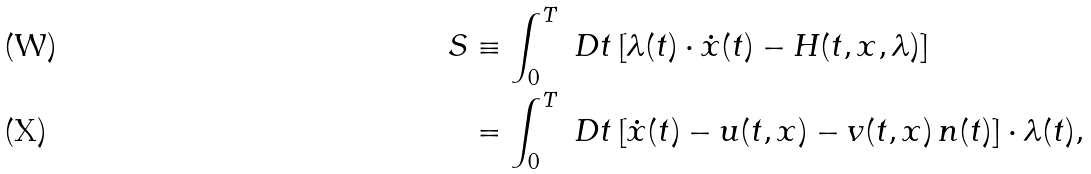<formula> <loc_0><loc_0><loc_500><loc_500>S & \equiv \int _ { 0 } ^ { T } \ D t \, [ \lambda ( t ) \cdot \dot { x } ( t ) - H ( t , x , \lambda ) ] \\ & = \int _ { 0 } ^ { T } \ D t \, [ \dot { x } ( t ) - u ( t , x ) - v ( t , x ) \, n ( t ) ] \cdot \lambda ( t ) ,</formula> 